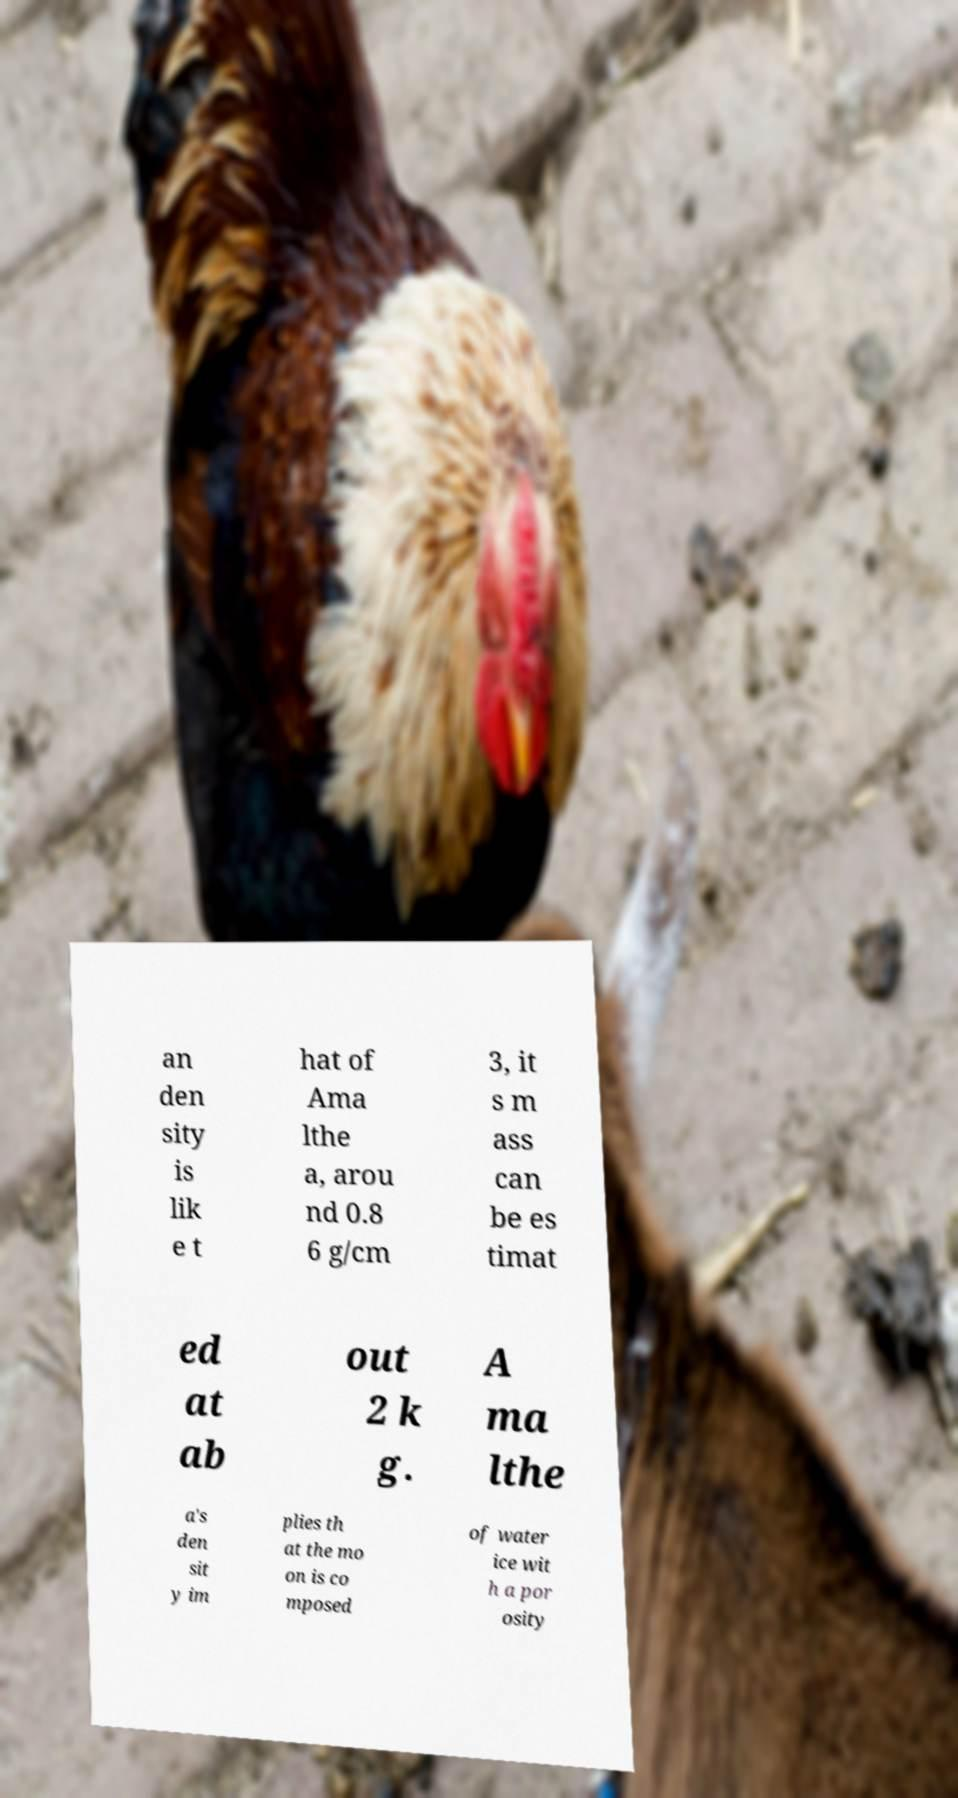I need the written content from this picture converted into text. Can you do that? an den sity is lik e t hat of Ama lthe a, arou nd 0.8 6 g/cm 3, it s m ass can be es timat ed at ab out 2 k g. A ma lthe a's den sit y im plies th at the mo on is co mposed of water ice wit h a por osity 